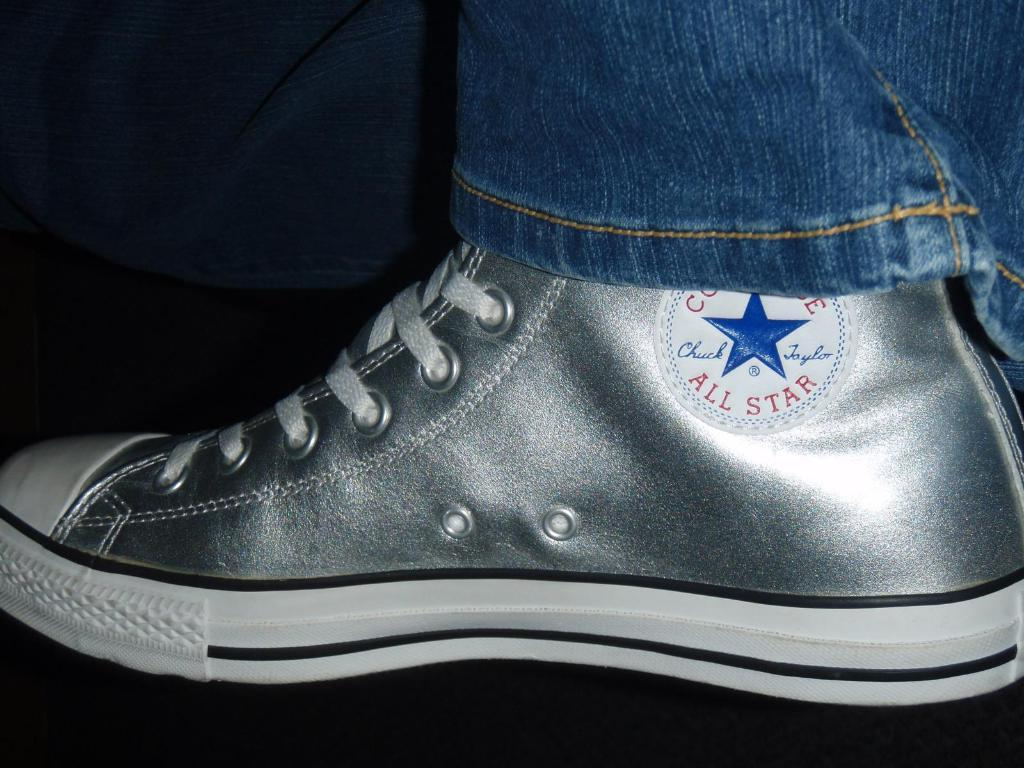What object is the main focus of the image? There is a shoe in the image. What can be found on the shoe? There is text on the shoe. How are the shoe's laces secured? The shoe has laces. What can be seen in the top right corner of the image? The edge of a pair of jeans is visible in the top right corner of the image. What is the color of the background in the image? The background of the image is dark. What type of mountain can be seen in the background of the image? There is no mountain present in the image; the background is dark. How many ducks are visible on the shoe in the image? There are no ducks present on the shoe in the image. 